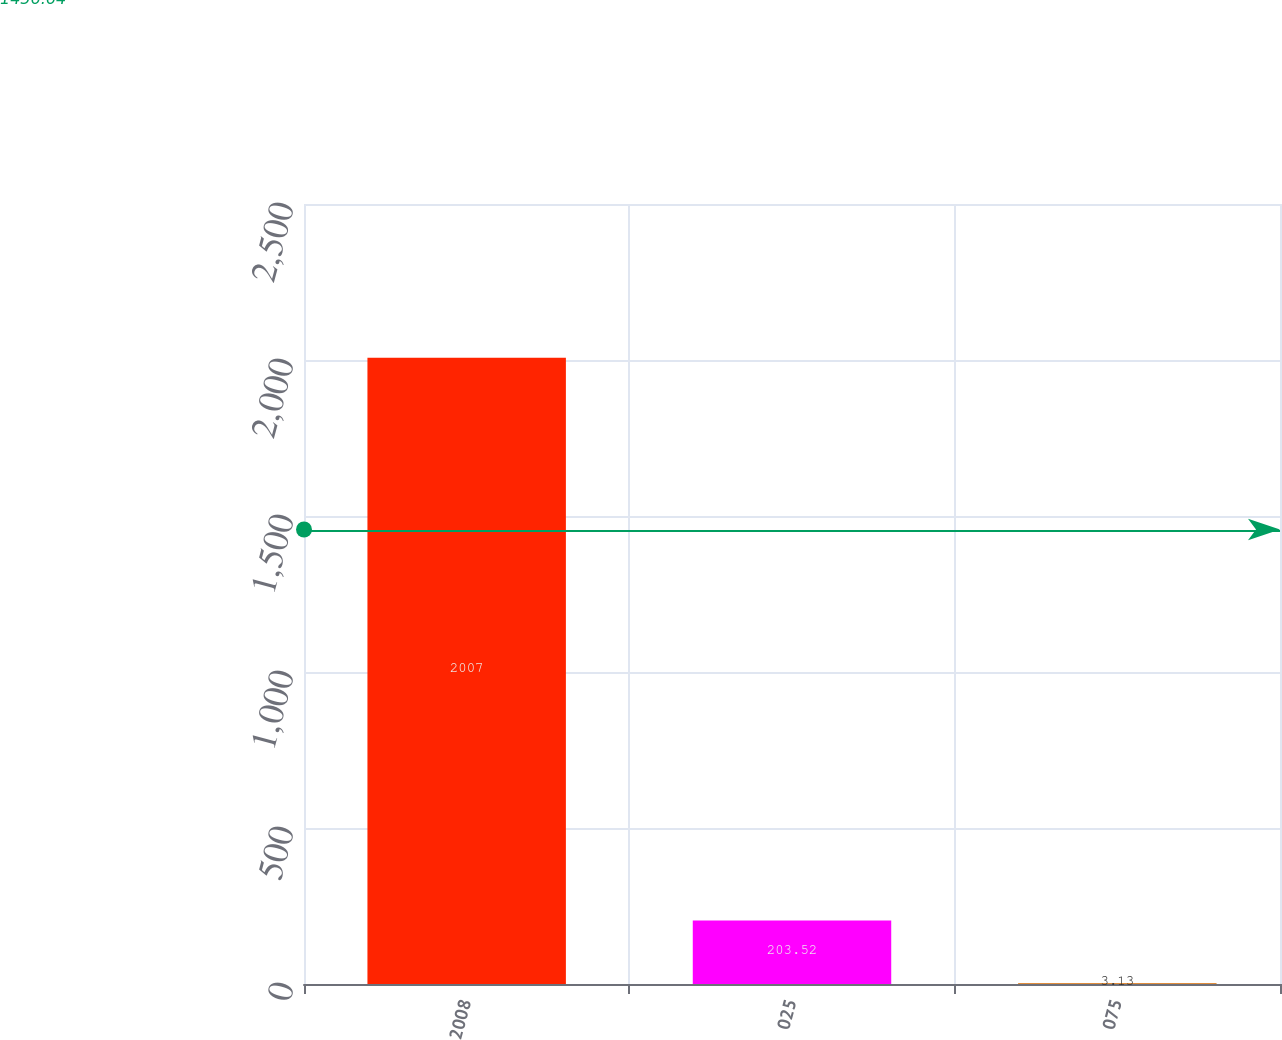<chart> <loc_0><loc_0><loc_500><loc_500><bar_chart><fcel>2008<fcel>025<fcel>075<nl><fcel>2007<fcel>203.52<fcel>3.13<nl></chart> 